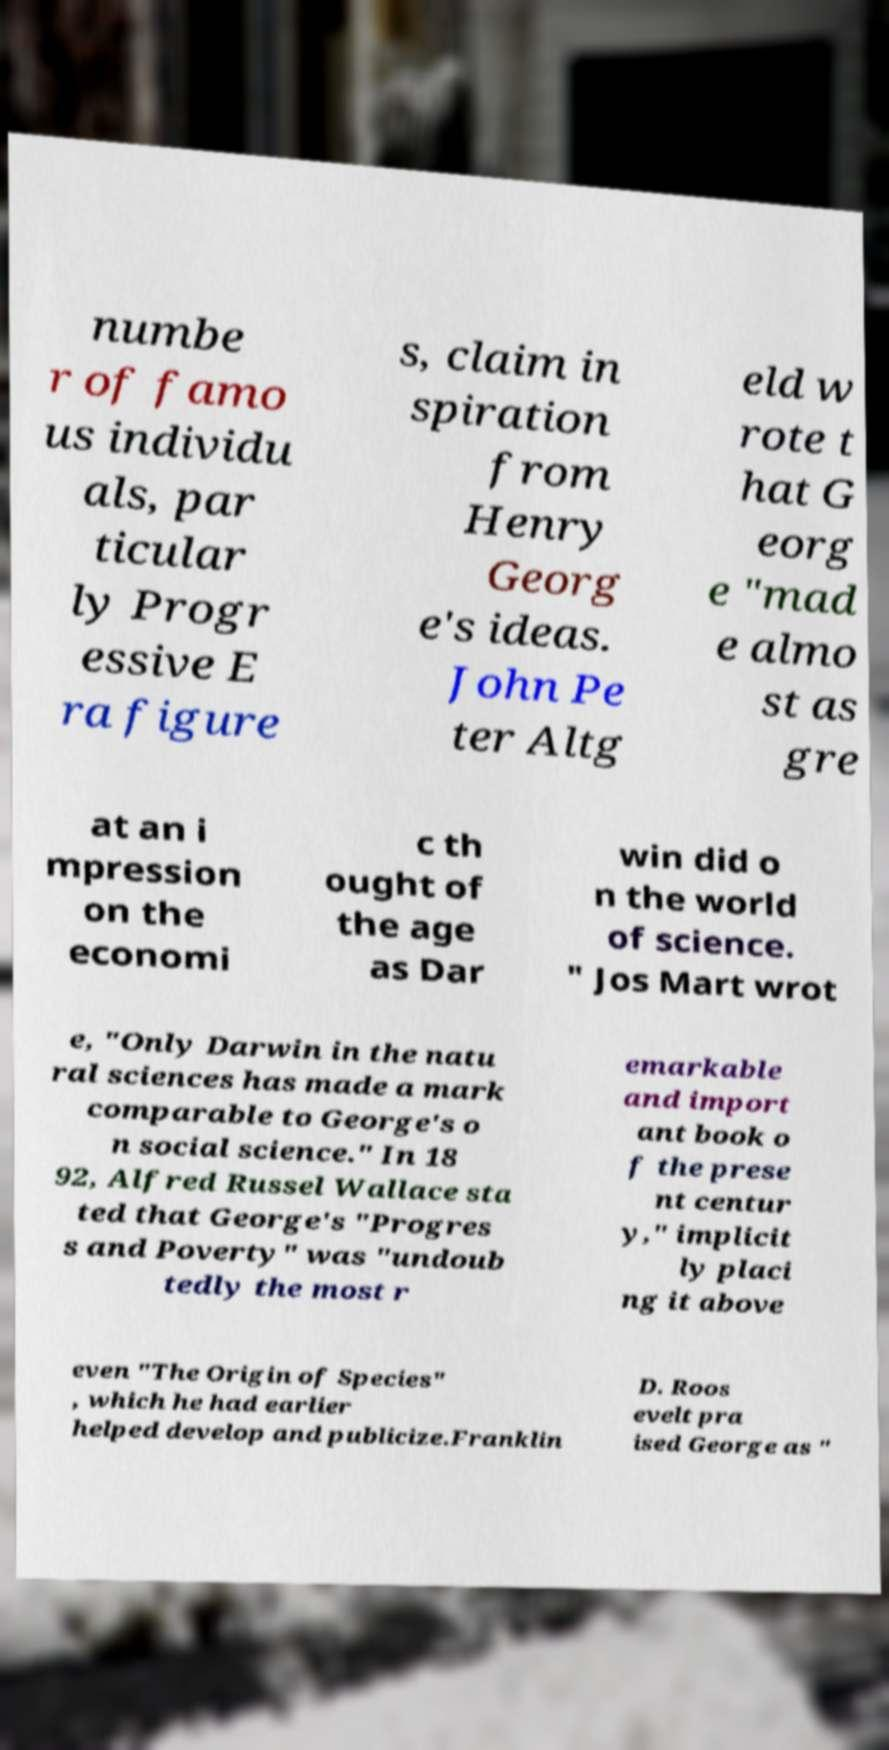Could you extract and type out the text from this image? numbe r of famo us individu als, par ticular ly Progr essive E ra figure s, claim in spiration from Henry Georg e's ideas. John Pe ter Altg eld w rote t hat G eorg e "mad e almo st as gre at an i mpression on the economi c th ought of the age as Dar win did o n the world of science. " Jos Mart wrot e, "Only Darwin in the natu ral sciences has made a mark comparable to George's o n social science." In 18 92, Alfred Russel Wallace sta ted that George's "Progres s and Poverty" was "undoub tedly the most r emarkable and import ant book o f the prese nt centur y," implicit ly placi ng it above even "The Origin of Species" , which he had earlier helped develop and publicize.Franklin D. Roos evelt pra ised George as " 